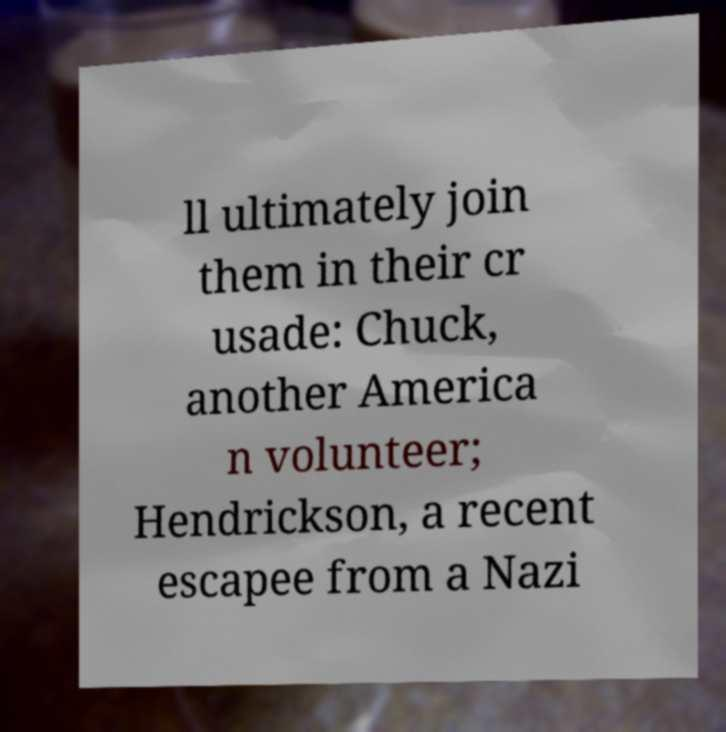For documentation purposes, I need the text within this image transcribed. Could you provide that? ll ultimately join them in their cr usade: Chuck, another America n volunteer; Hendrickson, a recent escapee from a Nazi 